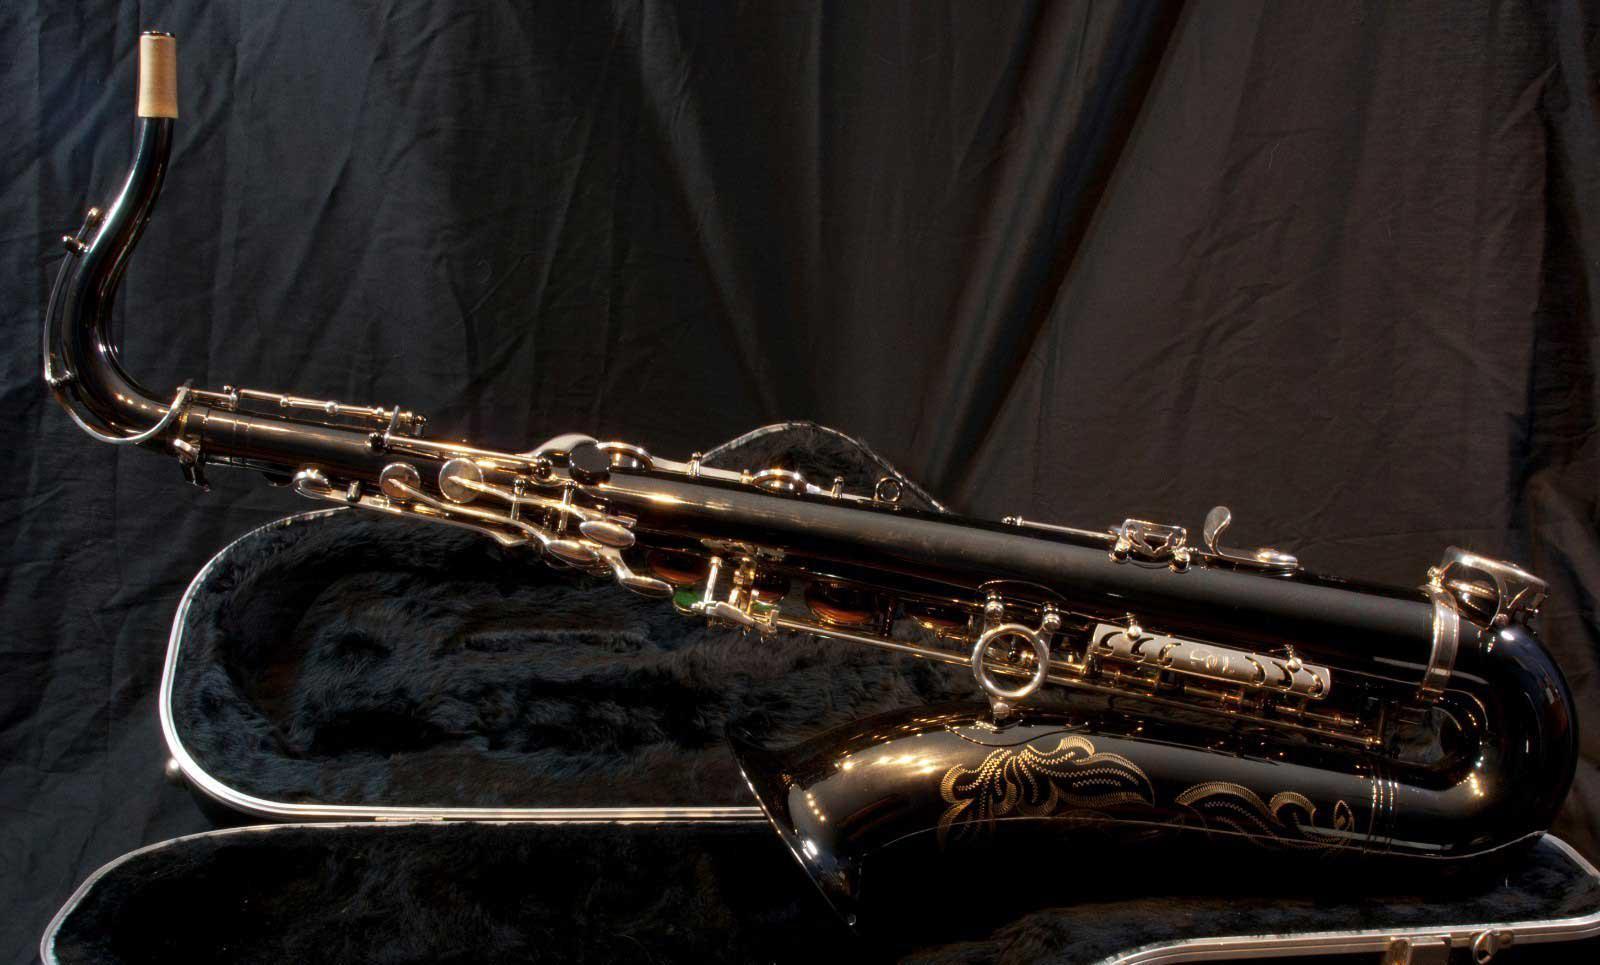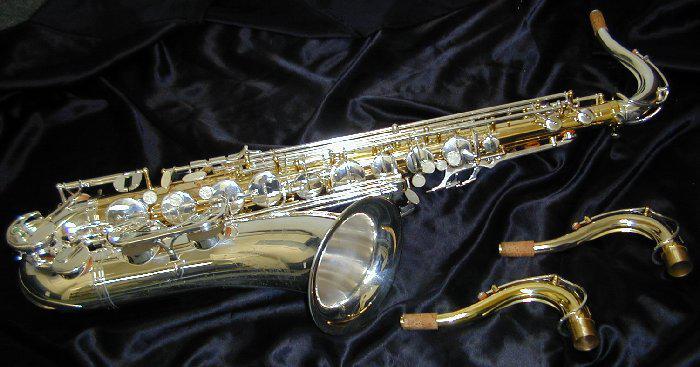The first image is the image on the left, the second image is the image on the right. Analyze the images presented: Is the assertion "One saxophone has two extra mouth pieces beside it and one saxophone is shown with a black lined case." valid? Answer yes or no. Yes. The first image is the image on the left, the second image is the image on the right. Analyze the images presented: Is the assertion "An image shows a saxophone displayed with its open, black-lined case." valid? Answer yes or no. Yes. 